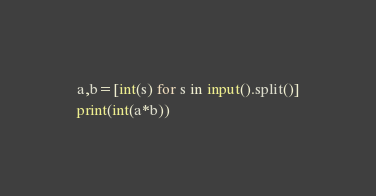Convert code to text. <code><loc_0><loc_0><loc_500><loc_500><_Python_>a,b=[int(s) for s in input().split()]
print(int(a*b))</code> 